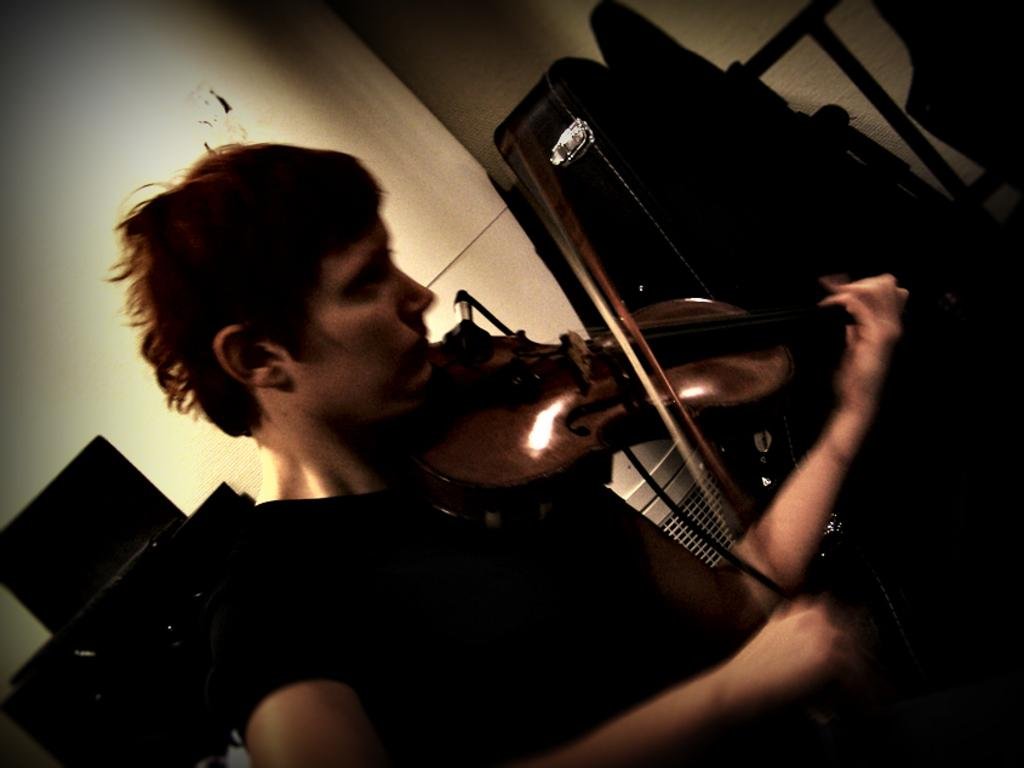What is the person in the image doing? The person is playing a violin. What instrument is the person playing in the image? The person is playing a violin. Is there any equipment related to the violin visible in the image? Yes, there is a violin bag in the image. What type of zephyr can be seen in the image? There is no zephyr present in the image. Is the person in the image discussing their insurance policy? There is no indication in the image that the person is discussing insurance. 